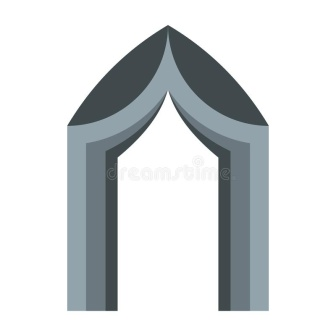How might this archway be represented in a futuristic city? In a futuristic city, this archway could be reimagined as a sleek, metallic structure, integrated seamlessly into the advanced architectural landscape. Its stone or concrete texture replaced with reflective materials like polished chrome or advanced polymers, creating a mesmerizing interplay of light and shadow. Equipped with smart technology, the archway could serve as an interactive portal, displaying historical information or holographic imagery for passersby. Sensors embedded within would monitor environmental conditions and crowd flow, optimizing urban management. Despite its futuristic facade, the archway would retain its symbolic essence, bridging the past with the present and future, a reminder of architectural lineage adapted to new horizons. 